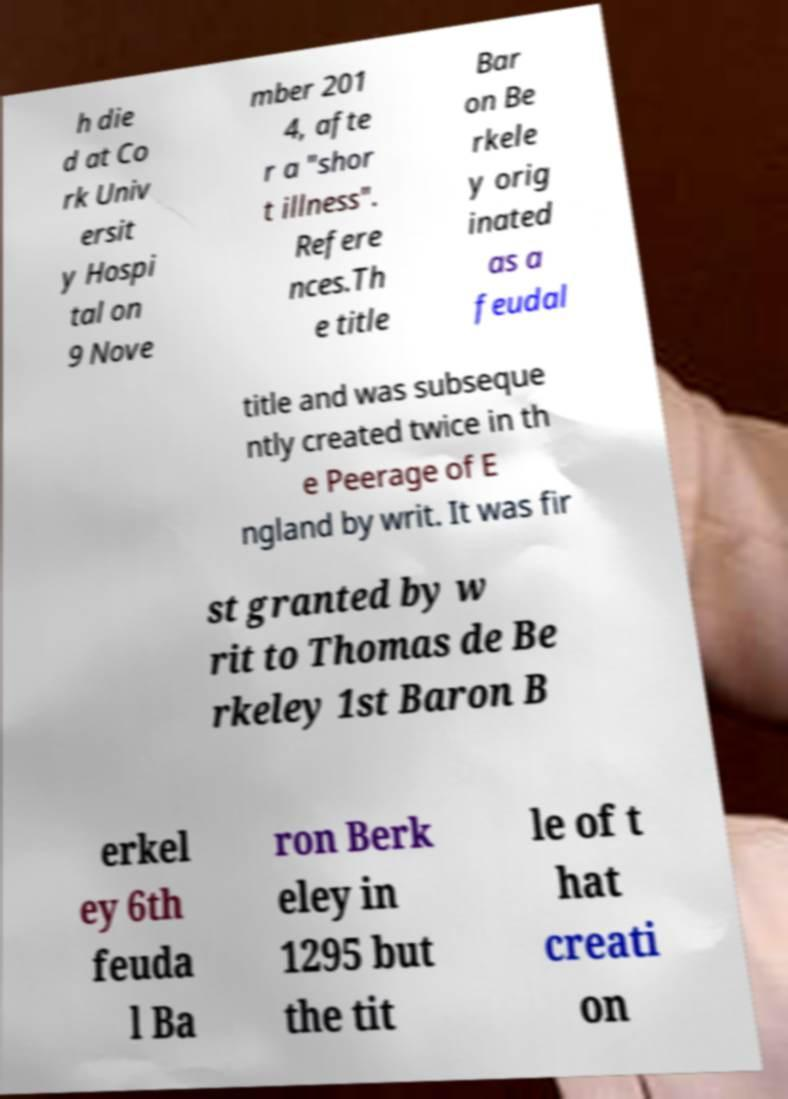Could you assist in decoding the text presented in this image and type it out clearly? h die d at Co rk Univ ersit y Hospi tal on 9 Nove mber 201 4, afte r a "shor t illness". Refere nces.Th e title Bar on Be rkele y orig inated as a feudal title and was subseque ntly created twice in th e Peerage of E ngland by writ. It was fir st granted by w rit to Thomas de Be rkeley 1st Baron B erkel ey 6th feuda l Ba ron Berk eley in 1295 but the tit le of t hat creati on 